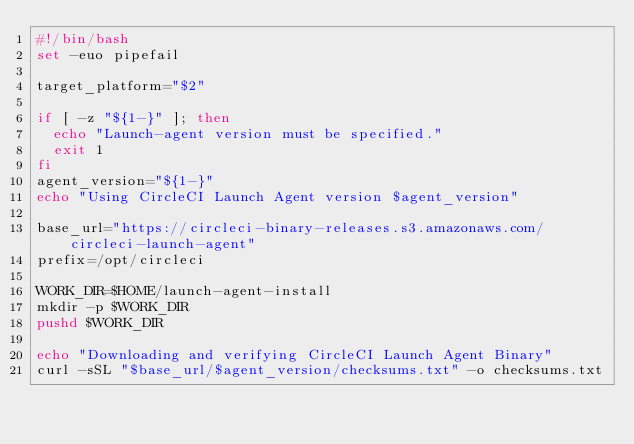<code> <loc_0><loc_0><loc_500><loc_500><_Bash_>#!/bin/bash
set -euo pipefail

target_platform="$2"

if [ -z "${1-}" ]; then
  echo "Launch-agent version must be specified."
  exit 1
fi
agent_version="${1-}"
echo "Using CircleCI Launch Agent version $agent_version"

base_url="https://circleci-binary-releases.s3.amazonaws.com/circleci-launch-agent"
prefix=/opt/circleci

WORK_DIR=$HOME/launch-agent-install
mkdir -p $WORK_DIR
pushd $WORK_DIR

echo "Downloading and verifying CircleCI Launch Agent Binary"
curl -sSL "$base_url/$agent_version/checksums.txt" -o checksums.txt</code> 